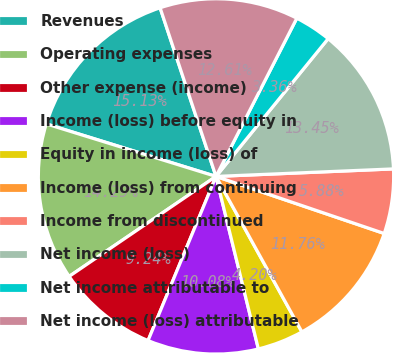<chart> <loc_0><loc_0><loc_500><loc_500><pie_chart><fcel>Revenues<fcel>Operating expenses<fcel>Other expense (income)<fcel>Income (loss) before equity in<fcel>Equity in income (loss) of<fcel>Income (loss) from continuing<fcel>Income from discontinued<fcel>Net income (loss)<fcel>Net income attributable to<fcel>Net income (loss) attributable<nl><fcel>15.13%<fcel>14.29%<fcel>9.24%<fcel>10.08%<fcel>4.2%<fcel>11.76%<fcel>5.88%<fcel>13.45%<fcel>3.36%<fcel>12.61%<nl></chart> 